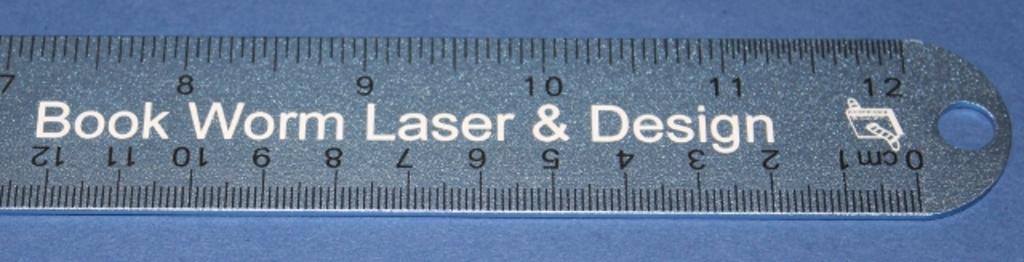What kind of worm is written on the ruler?
Offer a terse response. Book. Is this a laser and design ruler?
Provide a succinct answer. Yes. 